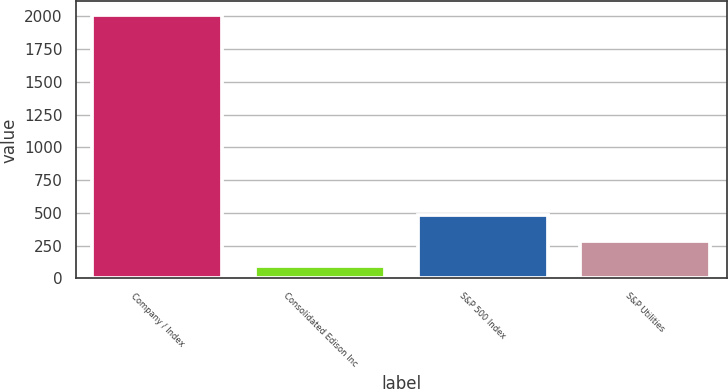<chart> <loc_0><loc_0><loc_500><loc_500><bar_chart><fcel>Company / Index<fcel>Consolidated Edison Inc<fcel>S&P 500 Index<fcel>S&P Utilities<nl><fcel>2013<fcel>96.81<fcel>480.05<fcel>288.43<nl></chart> 